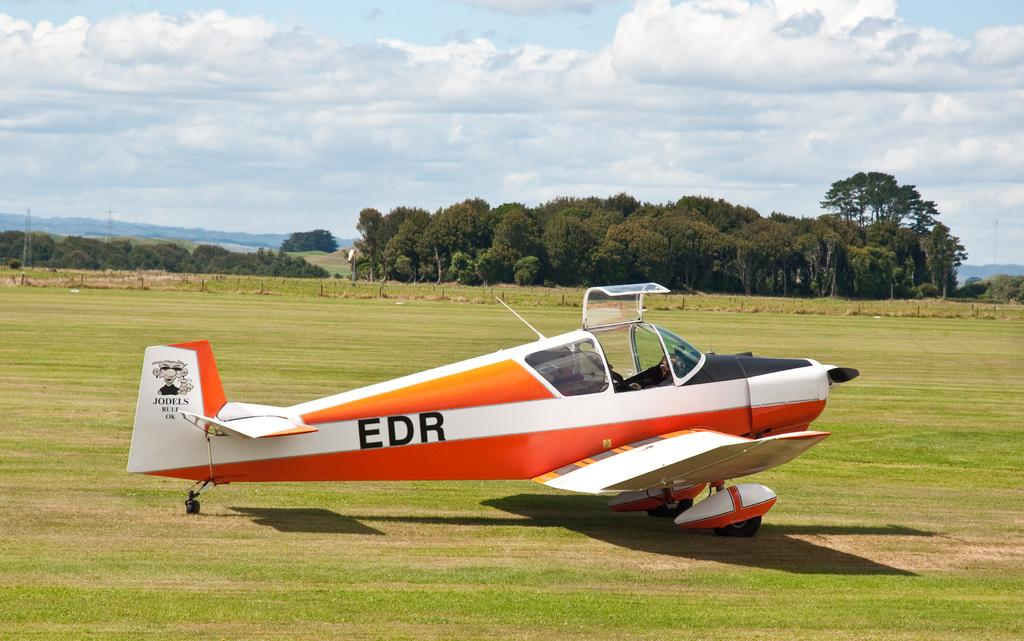What is the main subject of the image? The main subject of the image is an aircraft. Where is the aircraft located? The aircraft is on the grass. What can be seen in the background of the image? There are trees, plants, transmission towers, and a cloudy sky visible in the background of the image. What type of meat is being cooked in the bedroom in the image? There is no bedroom or meat present in the image; it features an aircraft on the grass with a background that includes trees, plants, transmission towers, and a cloudy sky. 